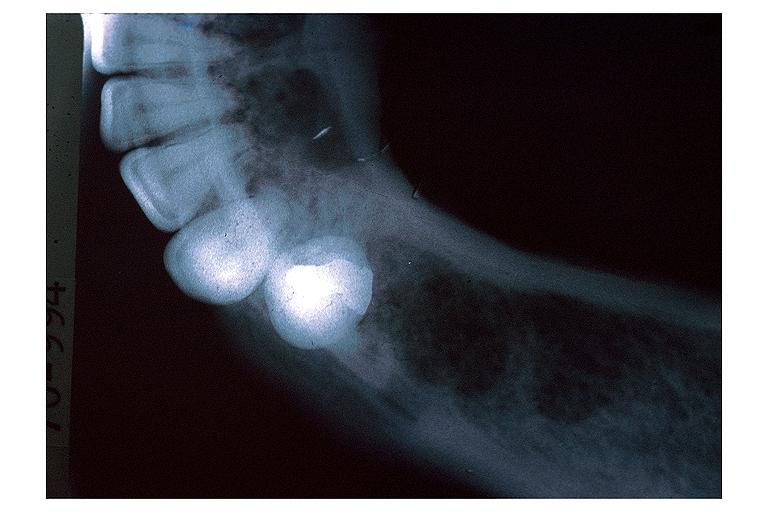what is present?
Answer the question using a single word or phrase. Oral 